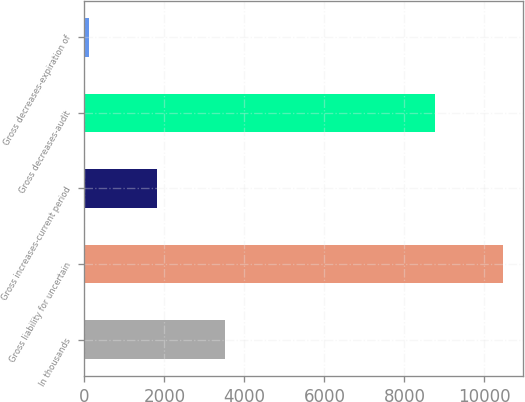Convert chart. <chart><loc_0><loc_0><loc_500><loc_500><bar_chart><fcel>In thousands<fcel>Gross liability for uncertain<fcel>Gross increases-current period<fcel>Gross decreases-audit<fcel>Gross decreases-expiration of<nl><fcel>3518<fcel>10451<fcel>1820<fcel>8753<fcel>122<nl></chart> 